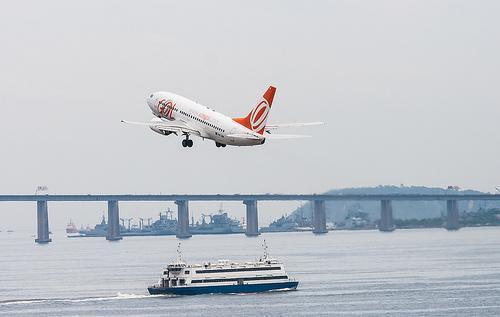How many planes in the photo?
Give a very brief answer. 1. How many pillars of the bridge are visible?
Give a very brief answer. 7. How many colors were used to paint the boat?
Give a very brief answer. 2. 